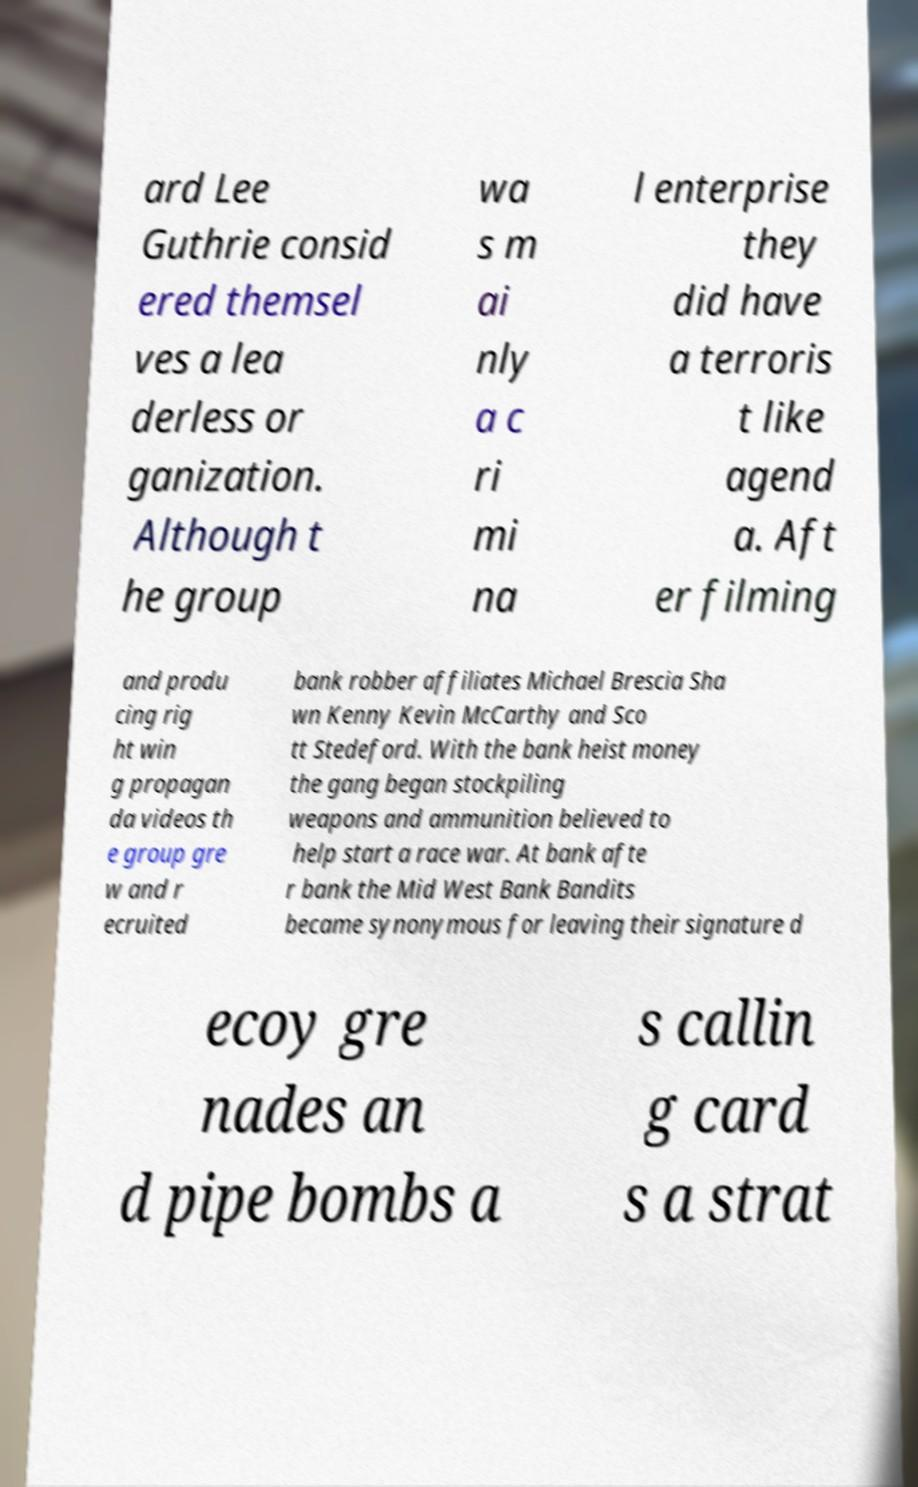I need the written content from this picture converted into text. Can you do that? ard Lee Guthrie consid ered themsel ves a lea derless or ganization. Although t he group wa s m ai nly a c ri mi na l enterprise they did have a terroris t like agend a. Aft er filming and produ cing rig ht win g propagan da videos th e group gre w and r ecruited bank robber affiliates Michael Brescia Sha wn Kenny Kevin McCarthy and Sco tt Stedeford. With the bank heist money the gang began stockpiling weapons and ammunition believed to help start a race war. At bank afte r bank the Mid West Bank Bandits became synonymous for leaving their signature d ecoy gre nades an d pipe bombs a s callin g card s a strat 